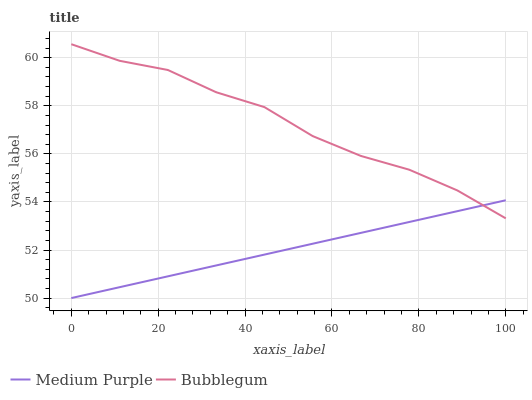Does Bubblegum have the minimum area under the curve?
Answer yes or no. No. Is Bubblegum the smoothest?
Answer yes or no. No. Does Bubblegum have the lowest value?
Answer yes or no. No. 